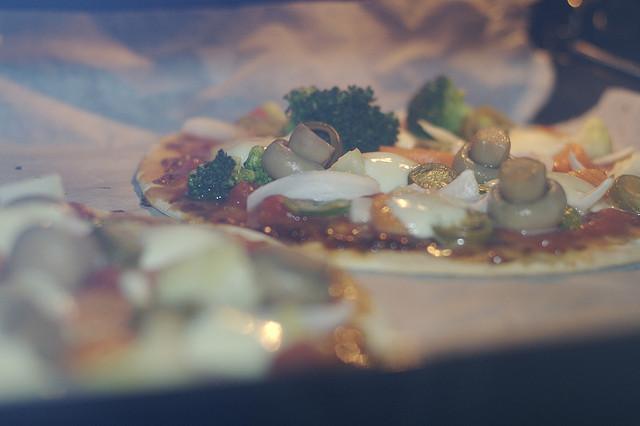How many blueberries are on the plate?
Give a very brief answer. 0. How many pizzas are there?
Give a very brief answer. 2. How many broccolis are in the picture?
Give a very brief answer. 2. 